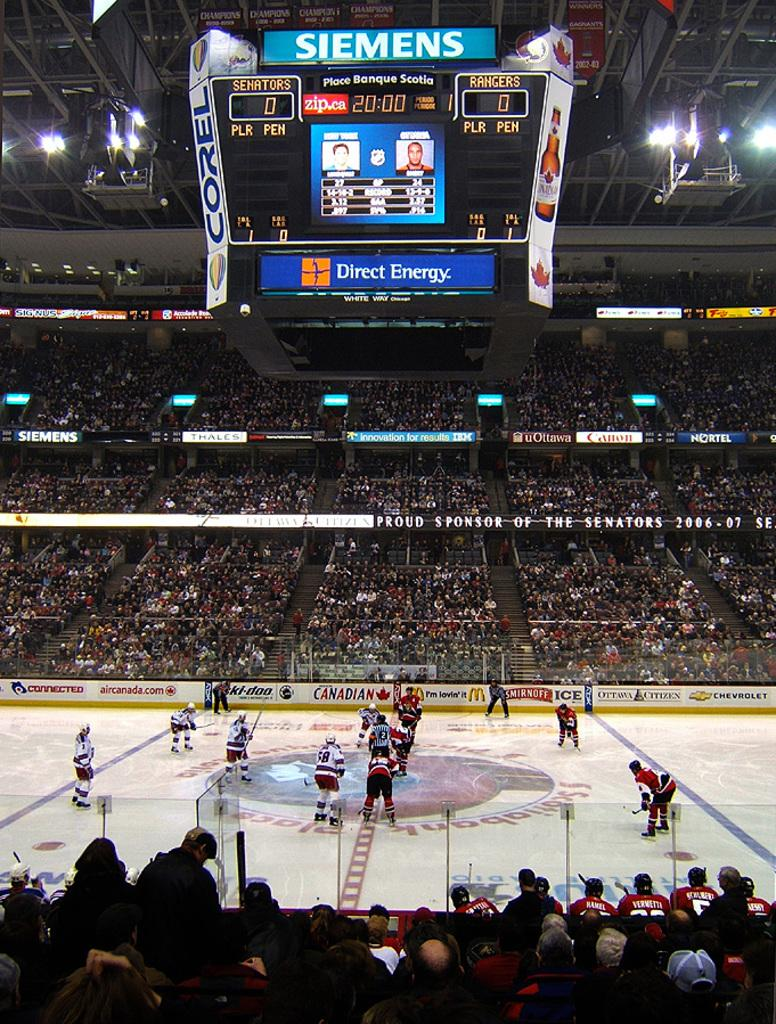<image>
Describe the image concisely. A ice hockey game being played in an arena with the word Siemens on the score board. 